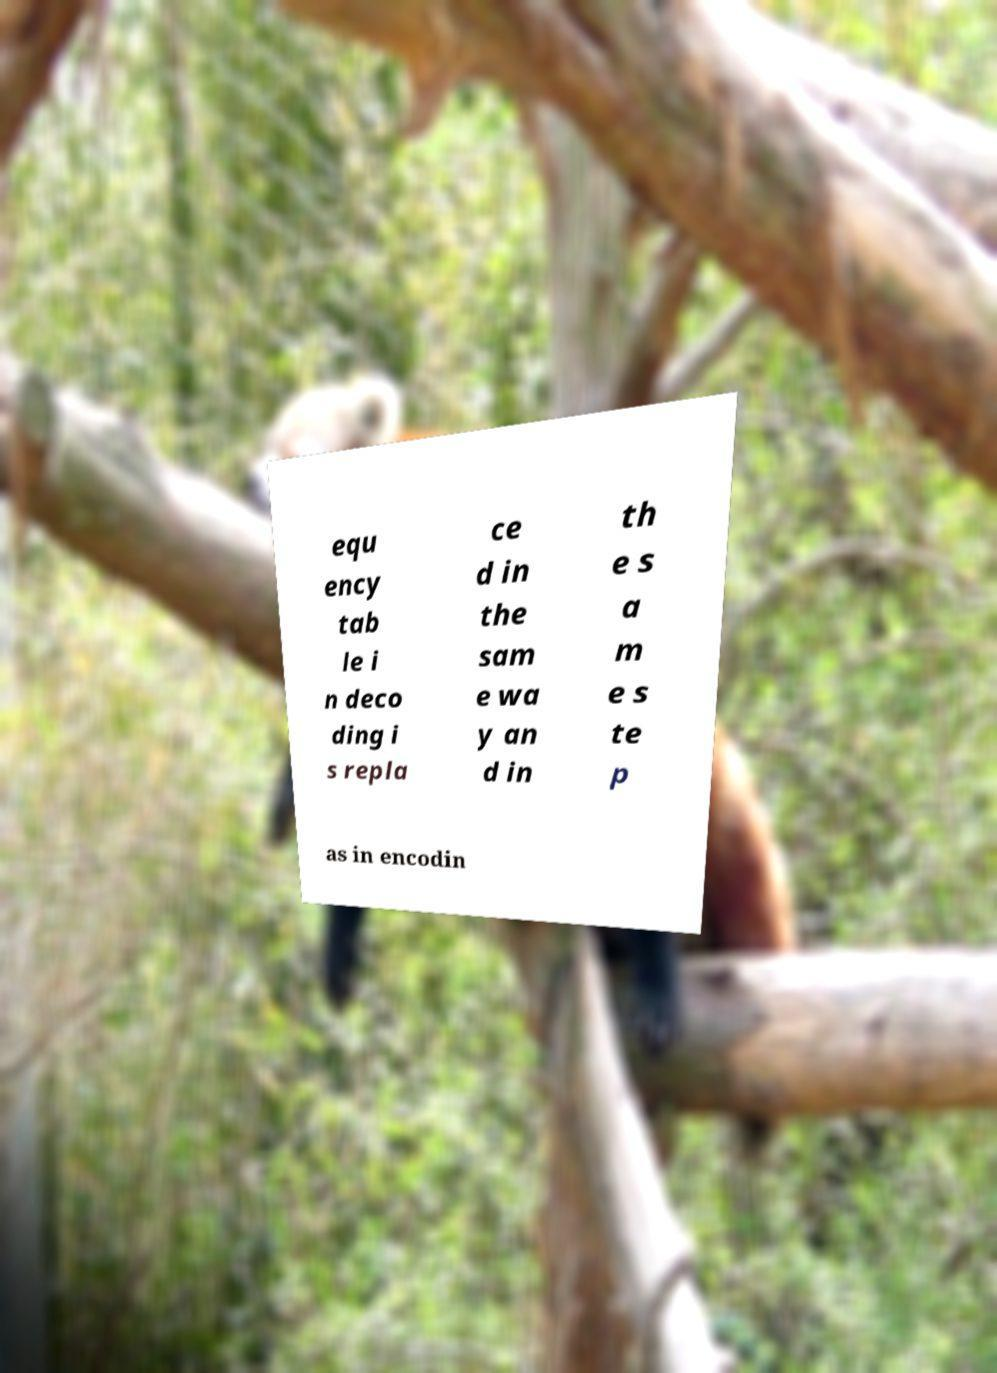I need the written content from this picture converted into text. Can you do that? equ ency tab le i n deco ding i s repla ce d in the sam e wa y an d in th e s a m e s te p as in encodin 